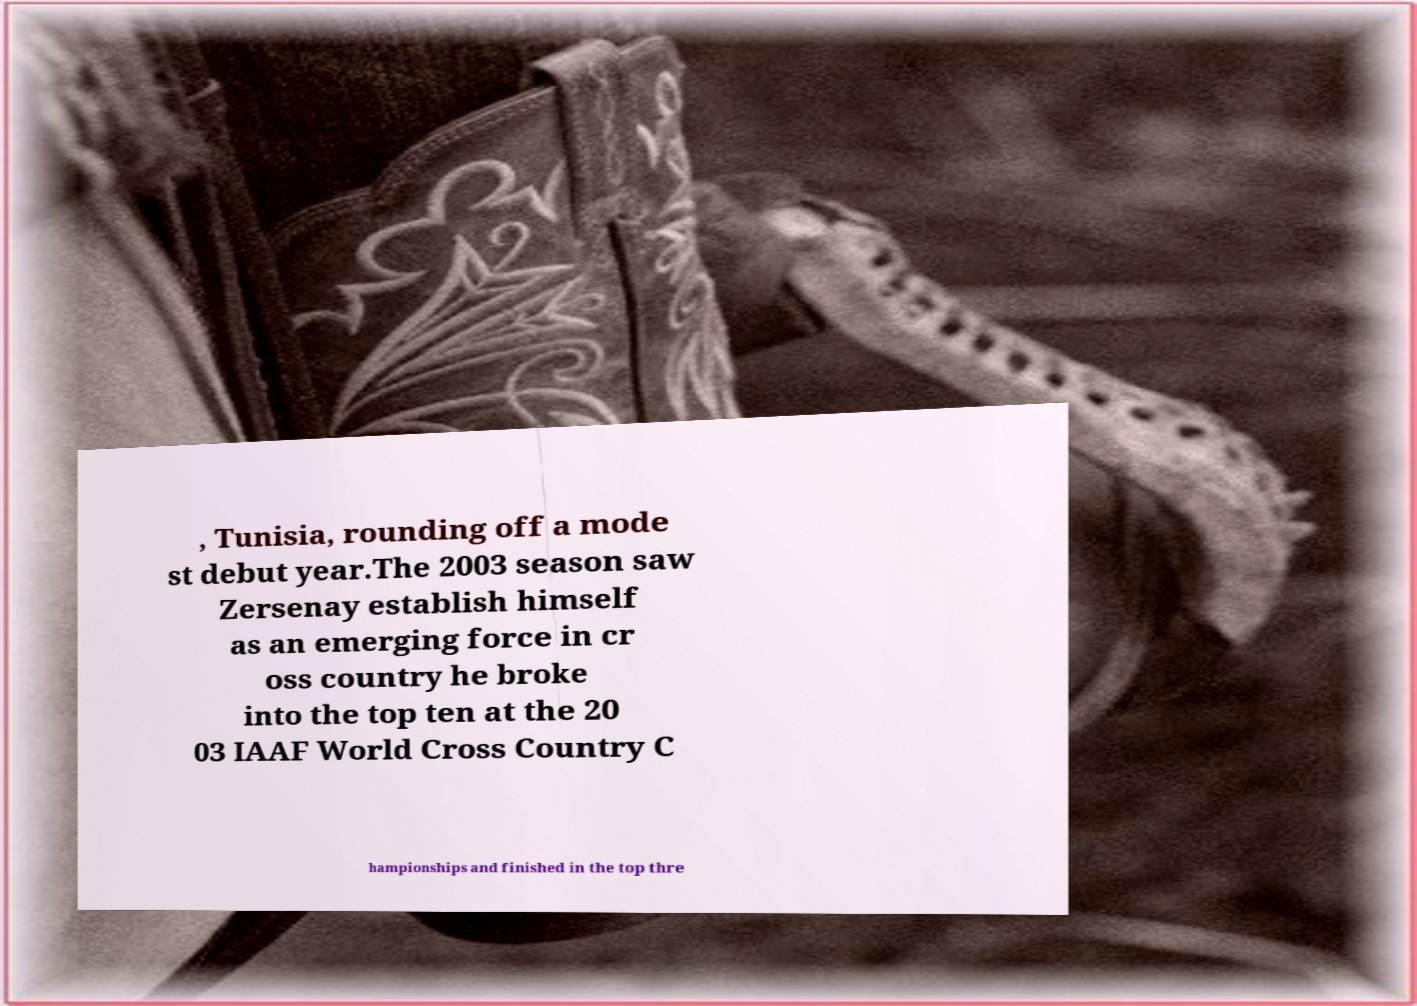For documentation purposes, I need the text within this image transcribed. Could you provide that? , Tunisia, rounding off a mode st debut year.The 2003 season saw Zersenay establish himself as an emerging force in cr oss country he broke into the top ten at the 20 03 IAAF World Cross Country C hampionships and finished in the top thre 